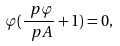<formula> <loc_0><loc_0><loc_500><loc_500>\varphi ( \frac { \ p \varphi } { \ p A } + 1 ) = 0 ,</formula> 